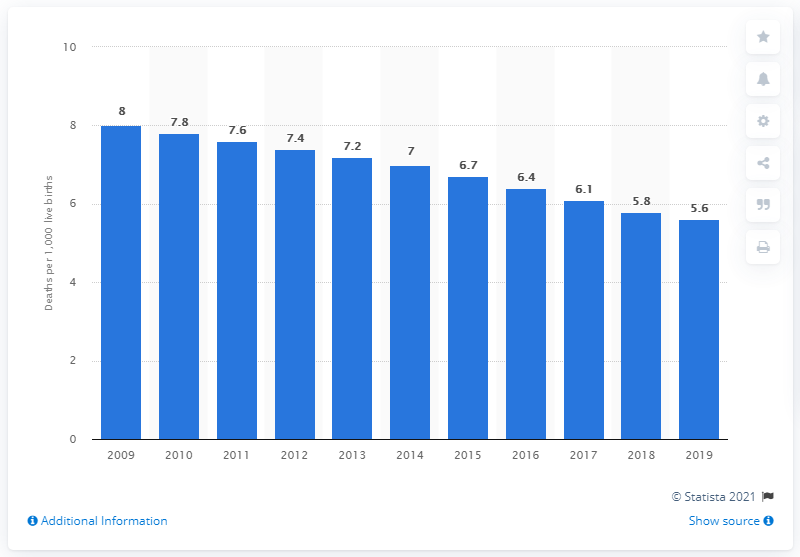Draw attention to some important aspects in this diagram. In 2019, the infant mortality rate in Qatar was 5.6 deaths per 1,000 live births. 